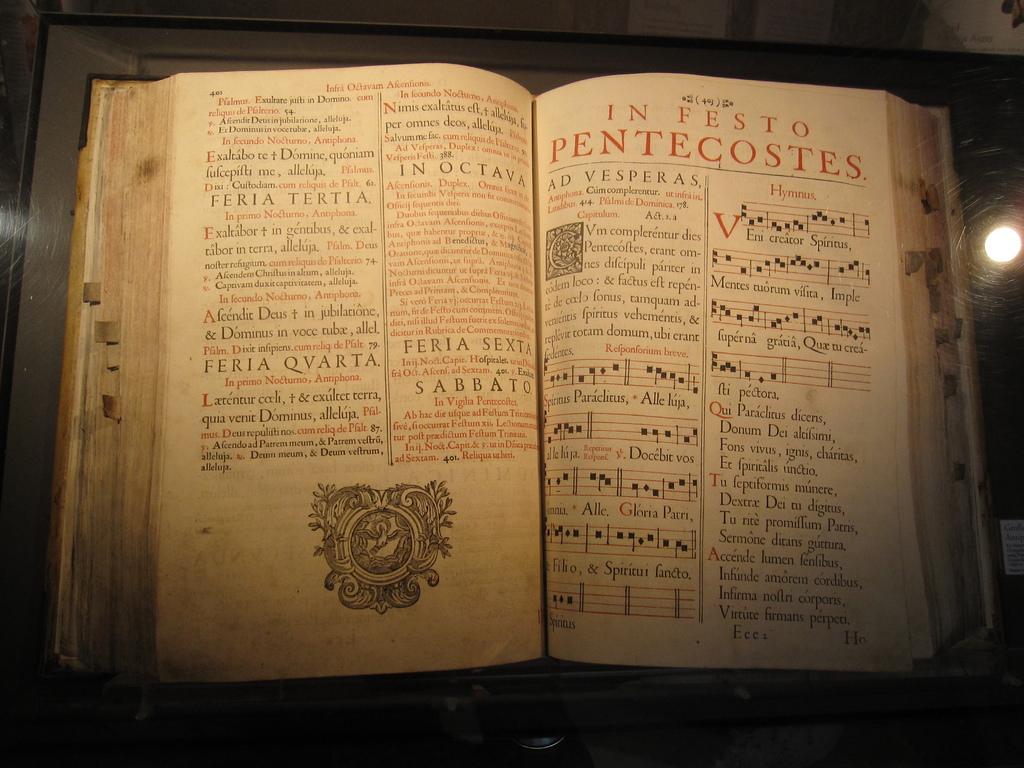What word is in smaller orange text on the right?
Your answer should be compact. Hymnus. 